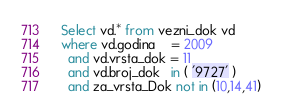Convert code to text. <code><loc_0><loc_0><loc_500><loc_500><_SQL_>Select vd.* from vezni_dok vd
where vd.godina    = 2009
  and vd.vrsta_dok = 11
  and vd.broj_dok   in ( '9727' )
  and za_vrsta_Dok not in (10,14,41)
</code> 